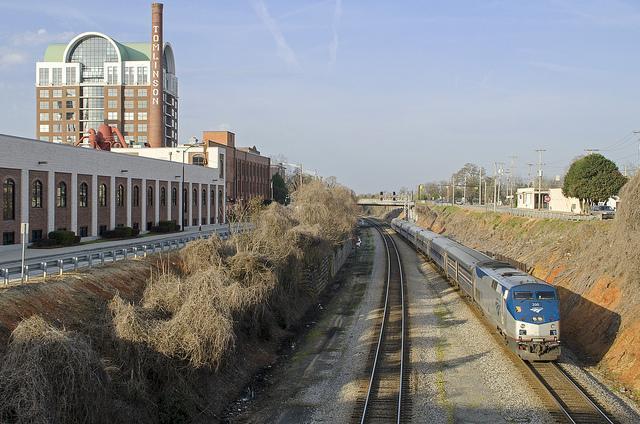How many trains are pictured?
Give a very brief answer. 1. 